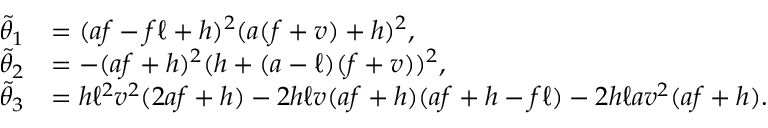Convert formula to latex. <formula><loc_0><loc_0><loc_500><loc_500>\begin{array} { r l } { \tilde { \theta } _ { 1 } } & { = ( a f - f \ell + h ) ^ { 2 } ( a ( f + v ) + h ) ^ { 2 } , } \\ { \tilde { \theta } _ { 2 } } & { = - ( a f + h ) ^ { 2 } ( h + ( a - \ell ) ( f + v ) ) ^ { 2 } , } \\ { \tilde { \theta } _ { 3 } } & { = h \ell ^ { 2 } v ^ { 2 } ( 2 a f + h ) - 2 h \ell v ( a f + h ) ( a f + h - f \ell ) - 2 h \ell a v ^ { 2 } ( a f + h ) . } \end{array}</formula> 